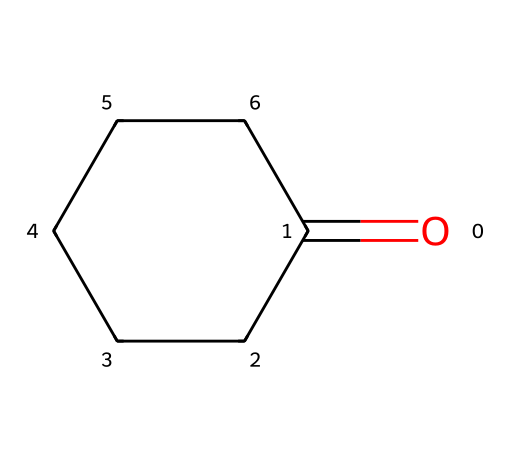What is the molecular formula of cyclohexanone? The chemical structure can be analyzed to identify the number of each atom present. There is one carbonyl group (C=O) which indicates one oxygen atom, and the cyclohexane ring contributes six carbon atoms. Thus, the molecular formula is derived as C6H10O.
Answer: C6H10O How many carbon atoms are in cyclohexanone? The structure shows a six-membered ring made entirely of carbon atoms, along with one carbon from the carbonyl group (C=O), making a total of six carbon atoms.
Answer: six What type of functional group is present in cyclohexanone? The presence of the carbonyl group (C=O) indicates that this compound contains a ketone functional group, as it is situated within a carbon chain rather than at the end.
Answer: ketone What is the degree of saturation of cyclohexanone? To calculate the degree of saturation, we can use the formula: Degree of unsaturation = (number of carbons - number of hydrogens/2) + 1. For cyclohexanone (C6H10O), it results in a degree of saturation of 1, reflecting the presence of one ring or double bond.
Answer: 1 Is cyclohexanone a saturated or unsaturated compound? Given that cyclohexanone contains a carbonyl group and maintains a six-membered ring, it does not have all single bonds and thus is considered unsaturated.
Answer: unsaturated What characteristic of cycloalkanes does cyclohexanone exemplify? Cyclohexanone, being a cyclic compound, exemplifies the structural property of cycloalkanes where carbon atoms are bonded in a ring formation, showcasing the unique stability and bonding configuration present in cyclic structures.
Answer: cyclic structure 